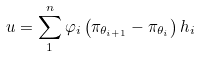Convert formula to latex. <formula><loc_0><loc_0><loc_500><loc_500>u = \sum _ { 1 } ^ { n } \varphi _ { i } \left ( \pi _ { \theta _ { i + 1 } } - \pi _ { \theta _ { i } } \right ) h _ { i }</formula> 